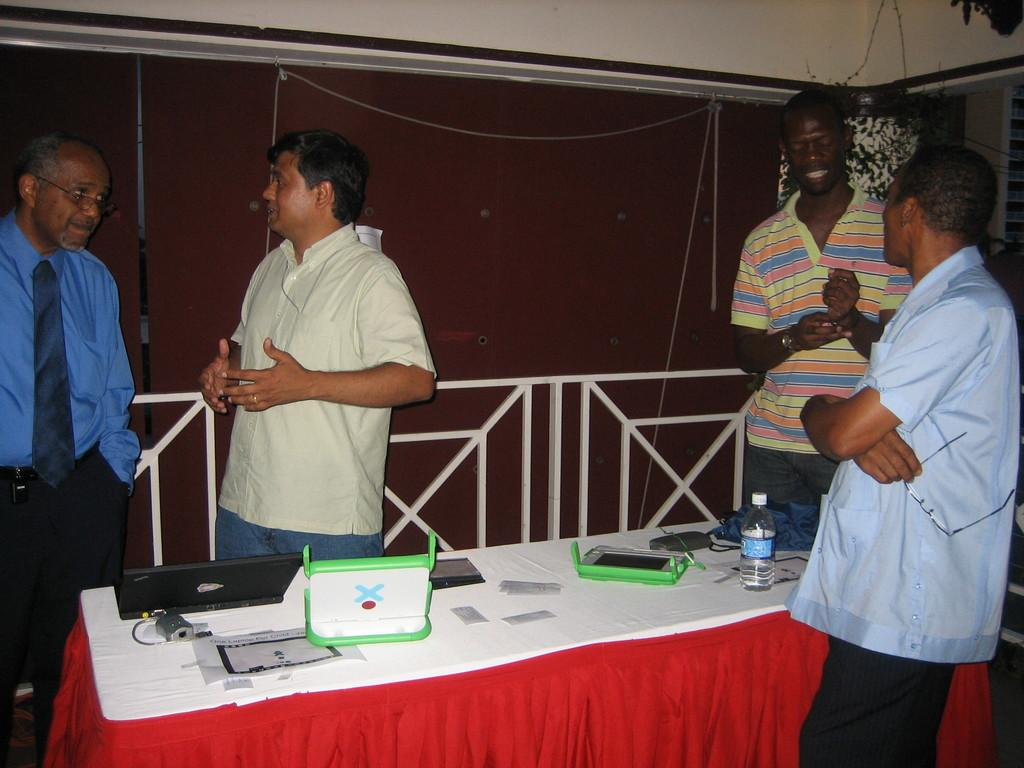How many people are present in the image? There are four people standing in the image. What objects are in front of the people? There is a laptop and a bottle in front of the people. What can be seen on the table in front of the people? There are objects on a table in front of the people. What is visible at the back side of the image? There is a wall at the back side of the image. How many sheep are visible in the image? There are no sheep present in the image. What advice does the grandfather give to the people in the image? There is no grandfather present in the image, so it is not possible to determine any advice given. 